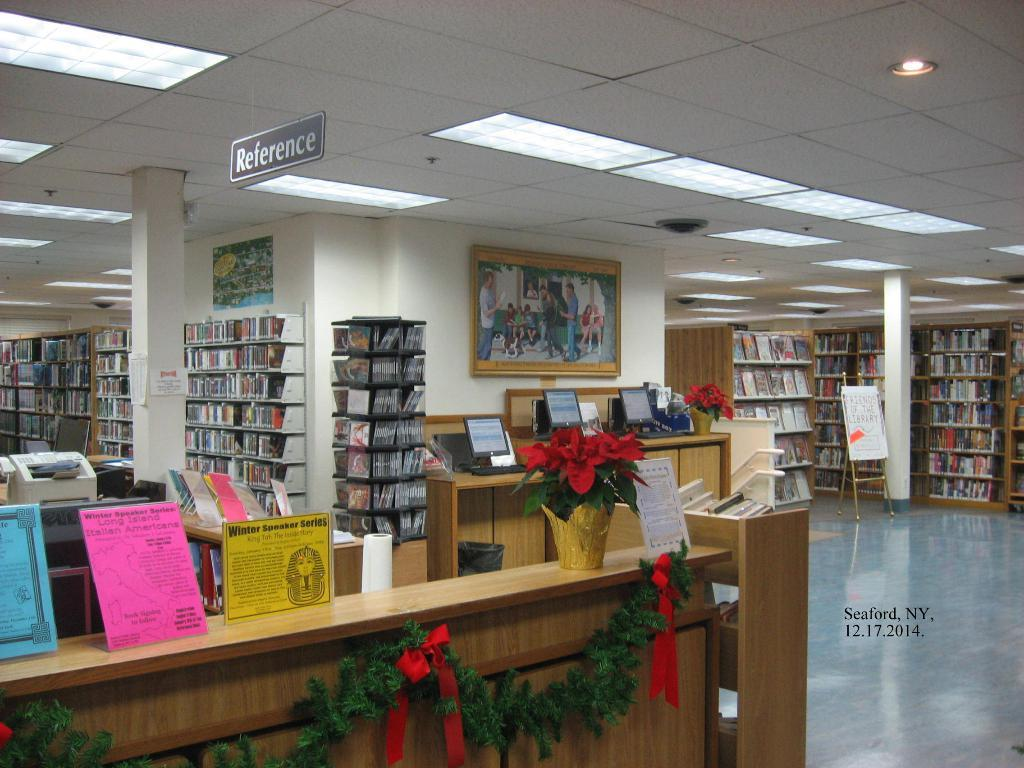<image>
Present a compact description of the photo's key features. Library with a sign above the bookcases that says reference. 